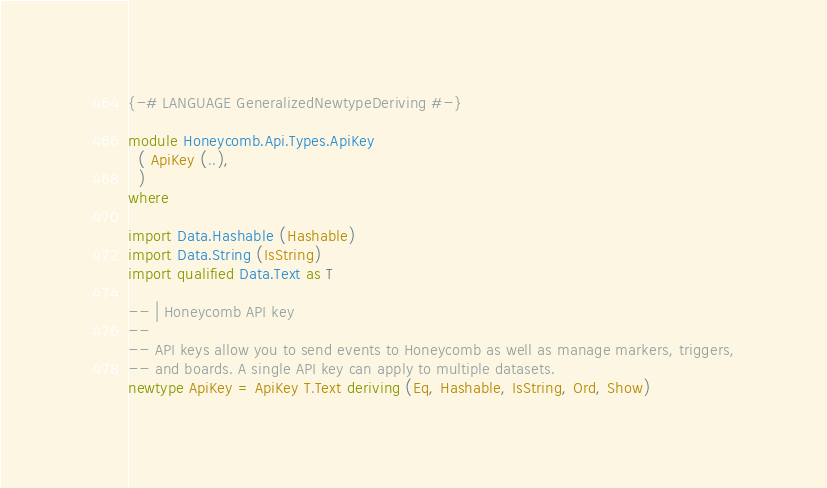<code> <loc_0><loc_0><loc_500><loc_500><_Haskell_>{-# LANGUAGE GeneralizedNewtypeDeriving #-}

module Honeycomb.Api.Types.ApiKey
  ( ApiKey (..),
  )
where

import Data.Hashable (Hashable)
import Data.String (IsString)
import qualified Data.Text as T

-- | Honeycomb API key
--
-- API keys allow you to send events to Honeycomb as well as manage markers, triggers,
-- and boards. A single API key can apply to multiple datasets.
newtype ApiKey = ApiKey T.Text deriving (Eq, Hashable, IsString, Ord, Show)
</code> 